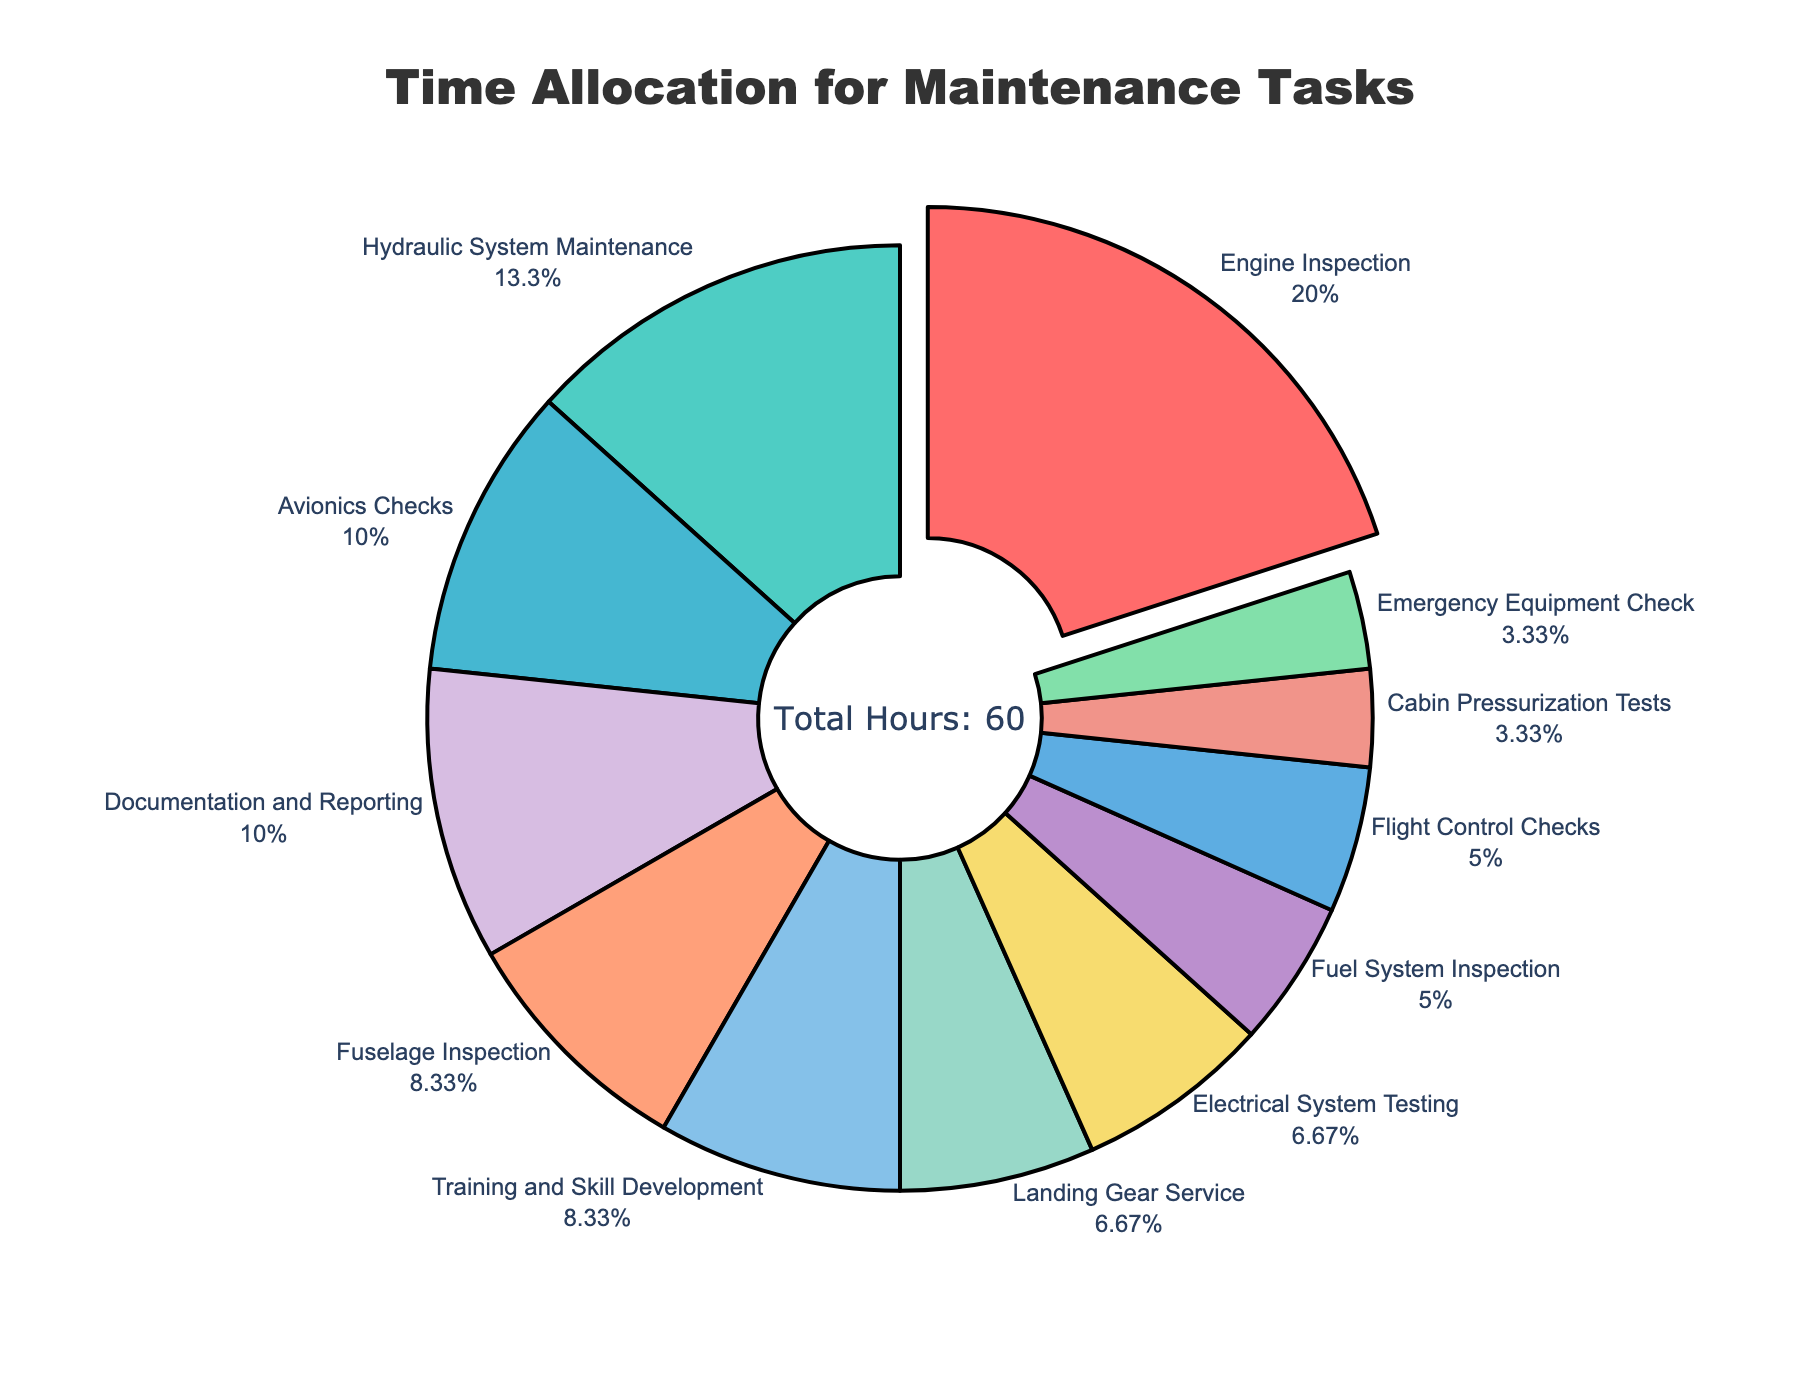What is the most time-consuming maintenance task? Referring to the pie chart, the largest section represents the task 'Engine Inspection' with the highest percentage.
Answer: Engine Inspection Which two tasks take up the same number of hours, and what are those hours? By examining the pie chart, both 'Landing Gear Service' and 'Electrical System Testing' are shown with equal slices, each representing 4 hours.
Answer: Landing Gear Service and Electrical System Testing, 4 hours How many total hours are spent on hydraulic and avionics maintenance combined? According to the chart, 'Hydraulic System Maintenance' takes 8 hours, and 'Avionics Checks' take 6 hours. Combining these hours, the sum is 8 + 6 = 14 hours.
Answer: 14 hours What percentage of the total time is allocated to 'Cabin Pressurization Tests' compared to 'Engine Inspection'? The pie chart indicates the total hours for each task. 'Cabin Pressurization Tests' take 2 hours, and 'Engine Inspection' takes 12 hours. The percentage is calculated as 2/12 * 100 = 16.67%.
Answer: 16.67% Which tasks are depicted using blue and green colors? By visually identifying the colors on the pie chart, 'Avionics Checks' are represented in blue while 'Hydraulic System Maintenance' is in green.
Answer: Avionics Checks and Hydraulic System Maintenance How much longer is the 'Training and Skill Development' task than the 'Emergency Equipment Check'? From the pie chart, 'Training and Skill Development' takes 5 hours whereas 'Emergency Equipment Check' takes 2 hours. The difference is 5 - 2 = 3 hours.
Answer: 3 hours What is the combined time for tasks classified under 'Documentation and Reporting' and 'Training and Skill Development'? According to the chart, 'Documentation and Reporting' takes 6 hours and 'Training and Skill Development' takes 5 hours. Adding these together, it sums to 6 + 5 = 11 hours.
Answer: 11 hours Compare the time spent on 'Fuel System Inspection' and 'Flight Control Checks.' Which one has more hours? The pie chart shows 'Fuel System Inspection' with 3 hours and 'Flight Control Checks' also with 3 hours. Since the hours are equal, neither task has more hours than the other.
Answer: Equal 